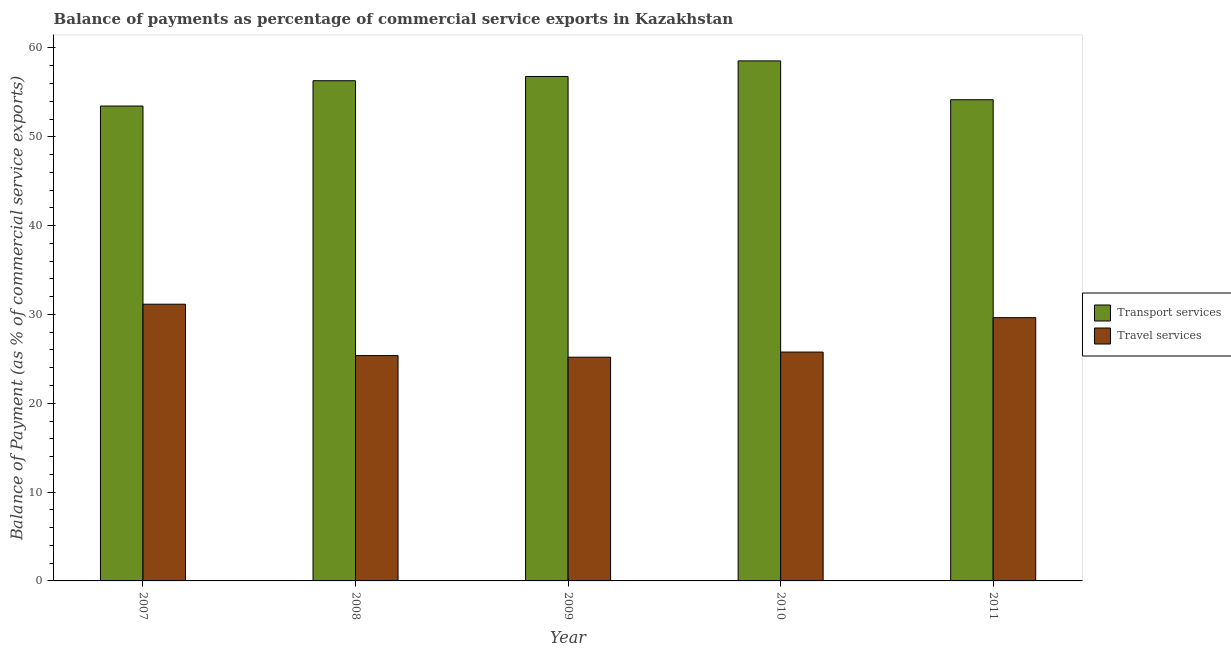How many different coloured bars are there?
Provide a short and direct response. 2. How many groups of bars are there?
Make the answer very short. 5. How many bars are there on the 2nd tick from the left?
Your answer should be very brief. 2. How many bars are there on the 1st tick from the right?
Provide a succinct answer. 2. What is the label of the 2nd group of bars from the left?
Your response must be concise. 2008. In how many cases, is the number of bars for a given year not equal to the number of legend labels?
Your answer should be compact. 0. What is the balance of payments of travel services in 2008?
Provide a short and direct response. 25.37. Across all years, what is the maximum balance of payments of transport services?
Offer a terse response. 58.54. Across all years, what is the minimum balance of payments of transport services?
Provide a succinct answer. 53.46. In which year was the balance of payments of travel services minimum?
Keep it short and to the point. 2009. What is the total balance of payments of travel services in the graph?
Make the answer very short. 137.1. What is the difference between the balance of payments of transport services in 2008 and that in 2009?
Your response must be concise. -0.48. What is the difference between the balance of payments of transport services in 2011 and the balance of payments of travel services in 2009?
Your answer should be very brief. -2.62. What is the average balance of payments of travel services per year?
Provide a succinct answer. 27.42. What is the ratio of the balance of payments of transport services in 2007 to that in 2010?
Provide a short and direct response. 0.91. What is the difference between the highest and the second highest balance of payments of transport services?
Give a very brief answer. 1.76. What is the difference between the highest and the lowest balance of payments of transport services?
Your answer should be very brief. 5.08. What does the 2nd bar from the left in 2011 represents?
Your answer should be compact. Travel services. What does the 1st bar from the right in 2010 represents?
Your answer should be compact. Travel services. Are all the bars in the graph horizontal?
Keep it short and to the point. No. How many years are there in the graph?
Your answer should be compact. 5. Are the values on the major ticks of Y-axis written in scientific E-notation?
Keep it short and to the point. No. Does the graph contain any zero values?
Give a very brief answer. No. Where does the legend appear in the graph?
Your answer should be very brief. Center right. What is the title of the graph?
Your response must be concise. Balance of payments as percentage of commercial service exports in Kazakhstan. Does "International Tourists" appear as one of the legend labels in the graph?
Your answer should be compact. No. What is the label or title of the X-axis?
Offer a terse response. Year. What is the label or title of the Y-axis?
Ensure brevity in your answer.  Balance of Payment (as % of commercial service exports). What is the Balance of Payment (as % of commercial service exports) of Transport services in 2007?
Your answer should be compact. 53.46. What is the Balance of Payment (as % of commercial service exports) in Travel services in 2007?
Provide a succinct answer. 31.15. What is the Balance of Payment (as % of commercial service exports) in Transport services in 2008?
Provide a succinct answer. 56.31. What is the Balance of Payment (as % of commercial service exports) of Travel services in 2008?
Provide a short and direct response. 25.37. What is the Balance of Payment (as % of commercial service exports) in Transport services in 2009?
Offer a very short reply. 56.79. What is the Balance of Payment (as % of commercial service exports) of Travel services in 2009?
Offer a very short reply. 25.19. What is the Balance of Payment (as % of commercial service exports) of Transport services in 2010?
Your response must be concise. 58.54. What is the Balance of Payment (as % of commercial service exports) of Travel services in 2010?
Offer a terse response. 25.76. What is the Balance of Payment (as % of commercial service exports) in Transport services in 2011?
Make the answer very short. 54.17. What is the Balance of Payment (as % of commercial service exports) of Travel services in 2011?
Provide a succinct answer. 29.64. Across all years, what is the maximum Balance of Payment (as % of commercial service exports) in Transport services?
Your answer should be compact. 58.54. Across all years, what is the maximum Balance of Payment (as % of commercial service exports) in Travel services?
Provide a succinct answer. 31.15. Across all years, what is the minimum Balance of Payment (as % of commercial service exports) of Transport services?
Make the answer very short. 53.46. Across all years, what is the minimum Balance of Payment (as % of commercial service exports) of Travel services?
Give a very brief answer. 25.19. What is the total Balance of Payment (as % of commercial service exports) of Transport services in the graph?
Make the answer very short. 279.27. What is the total Balance of Payment (as % of commercial service exports) of Travel services in the graph?
Keep it short and to the point. 137.1. What is the difference between the Balance of Payment (as % of commercial service exports) of Transport services in 2007 and that in 2008?
Ensure brevity in your answer.  -2.85. What is the difference between the Balance of Payment (as % of commercial service exports) in Travel services in 2007 and that in 2008?
Provide a succinct answer. 5.78. What is the difference between the Balance of Payment (as % of commercial service exports) in Transport services in 2007 and that in 2009?
Offer a very short reply. -3.33. What is the difference between the Balance of Payment (as % of commercial service exports) in Travel services in 2007 and that in 2009?
Provide a succinct answer. 5.96. What is the difference between the Balance of Payment (as % of commercial service exports) of Transport services in 2007 and that in 2010?
Offer a terse response. -5.08. What is the difference between the Balance of Payment (as % of commercial service exports) in Travel services in 2007 and that in 2010?
Give a very brief answer. 5.39. What is the difference between the Balance of Payment (as % of commercial service exports) in Transport services in 2007 and that in 2011?
Your answer should be compact. -0.71. What is the difference between the Balance of Payment (as % of commercial service exports) in Travel services in 2007 and that in 2011?
Provide a short and direct response. 1.51. What is the difference between the Balance of Payment (as % of commercial service exports) of Transport services in 2008 and that in 2009?
Provide a succinct answer. -0.48. What is the difference between the Balance of Payment (as % of commercial service exports) in Travel services in 2008 and that in 2009?
Offer a very short reply. 0.18. What is the difference between the Balance of Payment (as % of commercial service exports) in Transport services in 2008 and that in 2010?
Your response must be concise. -2.24. What is the difference between the Balance of Payment (as % of commercial service exports) of Travel services in 2008 and that in 2010?
Offer a very short reply. -0.4. What is the difference between the Balance of Payment (as % of commercial service exports) of Transport services in 2008 and that in 2011?
Provide a short and direct response. 2.14. What is the difference between the Balance of Payment (as % of commercial service exports) of Travel services in 2008 and that in 2011?
Keep it short and to the point. -4.27. What is the difference between the Balance of Payment (as % of commercial service exports) of Transport services in 2009 and that in 2010?
Provide a short and direct response. -1.76. What is the difference between the Balance of Payment (as % of commercial service exports) of Travel services in 2009 and that in 2010?
Ensure brevity in your answer.  -0.58. What is the difference between the Balance of Payment (as % of commercial service exports) in Transport services in 2009 and that in 2011?
Offer a terse response. 2.62. What is the difference between the Balance of Payment (as % of commercial service exports) of Travel services in 2009 and that in 2011?
Offer a very short reply. -4.45. What is the difference between the Balance of Payment (as % of commercial service exports) in Transport services in 2010 and that in 2011?
Provide a succinct answer. 4.37. What is the difference between the Balance of Payment (as % of commercial service exports) of Travel services in 2010 and that in 2011?
Your answer should be compact. -3.87. What is the difference between the Balance of Payment (as % of commercial service exports) of Transport services in 2007 and the Balance of Payment (as % of commercial service exports) of Travel services in 2008?
Your response must be concise. 28.1. What is the difference between the Balance of Payment (as % of commercial service exports) in Transport services in 2007 and the Balance of Payment (as % of commercial service exports) in Travel services in 2009?
Your answer should be compact. 28.27. What is the difference between the Balance of Payment (as % of commercial service exports) of Transport services in 2007 and the Balance of Payment (as % of commercial service exports) of Travel services in 2010?
Keep it short and to the point. 27.7. What is the difference between the Balance of Payment (as % of commercial service exports) in Transport services in 2007 and the Balance of Payment (as % of commercial service exports) in Travel services in 2011?
Offer a terse response. 23.82. What is the difference between the Balance of Payment (as % of commercial service exports) of Transport services in 2008 and the Balance of Payment (as % of commercial service exports) of Travel services in 2009?
Your answer should be compact. 31.12. What is the difference between the Balance of Payment (as % of commercial service exports) in Transport services in 2008 and the Balance of Payment (as % of commercial service exports) in Travel services in 2010?
Provide a succinct answer. 30.55. What is the difference between the Balance of Payment (as % of commercial service exports) in Transport services in 2008 and the Balance of Payment (as % of commercial service exports) in Travel services in 2011?
Offer a very short reply. 26.67. What is the difference between the Balance of Payment (as % of commercial service exports) in Transport services in 2009 and the Balance of Payment (as % of commercial service exports) in Travel services in 2010?
Your answer should be compact. 31.03. What is the difference between the Balance of Payment (as % of commercial service exports) in Transport services in 2009 and the Balance of Payment (as % of commercial service exports) in Travel services in 2011?
Provide a succinct answer. 27.15. What is the difference between the Balance of Payment (as % of commercial service exports) of Transport services in 2010 and the Balance of Payment (as % of commercial service exports) of Travel services in 2011?
Offer a terse response. 28.91. What is the average Balance of Payment (as % of commercial service exports) in Transport services per year?
Offer a terse response. 55.85. What is the average Balance of Payment (as % of commercial service exports) of Travel services per year?
Your answer should be compact. 27.42. In the year 2007, what is the difference between the Balance of Payment (as % of commercial service exports) in Transport services and Balance of Payment (as % of commercial service exports) in Travel services?
Your answer should be very brief. 22.31. In the year 2008, what is the difference between the Balance of Payment (as % of commercial service exports) of Transport services and Balance of Payment (as % of commercial service exports) of Travel services?
Make the answer very short. 30.94. In the year 2009, what is the difference between the Balance of Payment (as % of commercial service exports) of Transport services and Balance of Payment (as % of commercial service exports) of Travel services?
Offer a terse response. 31.6. In the year 2010, what is the difference between the Balance of Payment (as % of commercial service exports) of Transport services and Balance of Payment (as % of commercial service exports) of Travel services?
Your answer should be very brief. 32.78. In the year 2011, what is the difference between the Balance of Payment (as % of commercial service exports) of Transport services and Balance of Payment (as % of commercial service exports) of Travel services?
Ensure brevity in your answer.  24.54. What is the ratio of the Balance of Payment (as % of commercial service exports) in Transport services in 2007 to that in 2008?
Provide a short and direct response. 0.95. What is the ratio of the Balance of Payment (as % of commercial service exports) in Travel services in 2007 to that in 2008?
Keep it short and to the point. 1.23. What is the ratio of the Balance of Payment (as % of commercial service exports) of Transport services in 2007 to that in 2009?
Offer a terse response. 0.94. What is the ratio of the Balance of Payment (as % of commercial service exports) in Travel services in 2007 to that in 2009?
Your response must be concise. 1.24. What is the ratio of the Balance of Payment (as % of commercial service exports) in Transport services in 2007 to that in 2010?
Make the answer very short. 0.91. What is the ratio of the Balance of Payment (as % of commercial service exports) in Travel services in 2007 to that in 2010?
Provide a short and direct response. 1.21. What is the ratio of the Balance of Payment (as % of commercial service exports) in Transport services in 2007 to that in 2011?
Give a very brief answer. 0.99. What is the ratio of the Balance of Payment (as % of commercial service exports) in Travel services in 2007 to that in 2011?
Make the answer very short. 1.05. What is the ratio of the Balance of Payment (as % of commercial service exports) in Travel services in 2008 to that in 2009?
Your response must be concise. 1.01. What is the ratio of the Balance of Payment (as % of commercial service exports) of Transport services in 2008 to that in 2010?
Your answer should be very brief. 0.96. What is the ratio of the Balance of Payment (as % of commercial service exports) of Travel services in 2008 to that in 2010?
Ensure brevity in your answer.  0.98. What is the ratio of the Balance of Payment (as % of commercial service exports) of Transport services in 2008 to that in 2011?
Offer a very short reply. 1.04. What is the ratio of the Balance of Payment (as % of commercial service exports) in Travel services in 2008 to that in 2011?
Ensure brevity in your answer.  0.86. What is the ratio of the Balance of Payment (as % of commercial service exports) in Travel services in 2009 to that in 2010?
Ensure brevity in your answer.  0.98. What is the ratio of the Balance of Payment (as % of commercial service exports) of Transport services in 2009 to that in 2011?
Provide a short and direct response. 1.05. What is the ratio of the Balance of Payment (as % of commercial service exports) of Travel services in 2009 to that in 2011?
Offer a very short reply. 0.85. What is the ratio of the Balance of Payment (as % of commercial service exports) in Transport services in 2010 to that in 2011?
Your answer should be very brief. 1.08. What is the ratio of the Balance of Payment (as % of commercial service exports) of Travel services in 2010 to that in 2011?
Give a very brief answer. 0.87. What is the difference between the highest and the second highest Balance of Payment (as % of commercial service exports) in Transport services?
Your response must be concise. 1.76. What is the difference between the highest and the second highest Balance of Payment (as % of commercial service exports) in Travel services?
Provide a short and direct response. 1.51. What is the difference between the highest and the lowest Balance of Payment (as % of commercial service exports) of Transport services?
Provide a succinct answer. 5.08. What is the difference between the highest and the lowest Balance of Payment (as % of commercial service exports) in Travel services?
Keep it short and to the point. 5.96. 